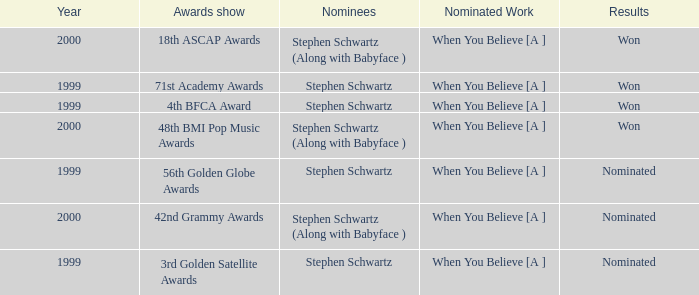Which nominated creation was victorious in 2000? When You Believe [A ], When You Believe [A ]. 